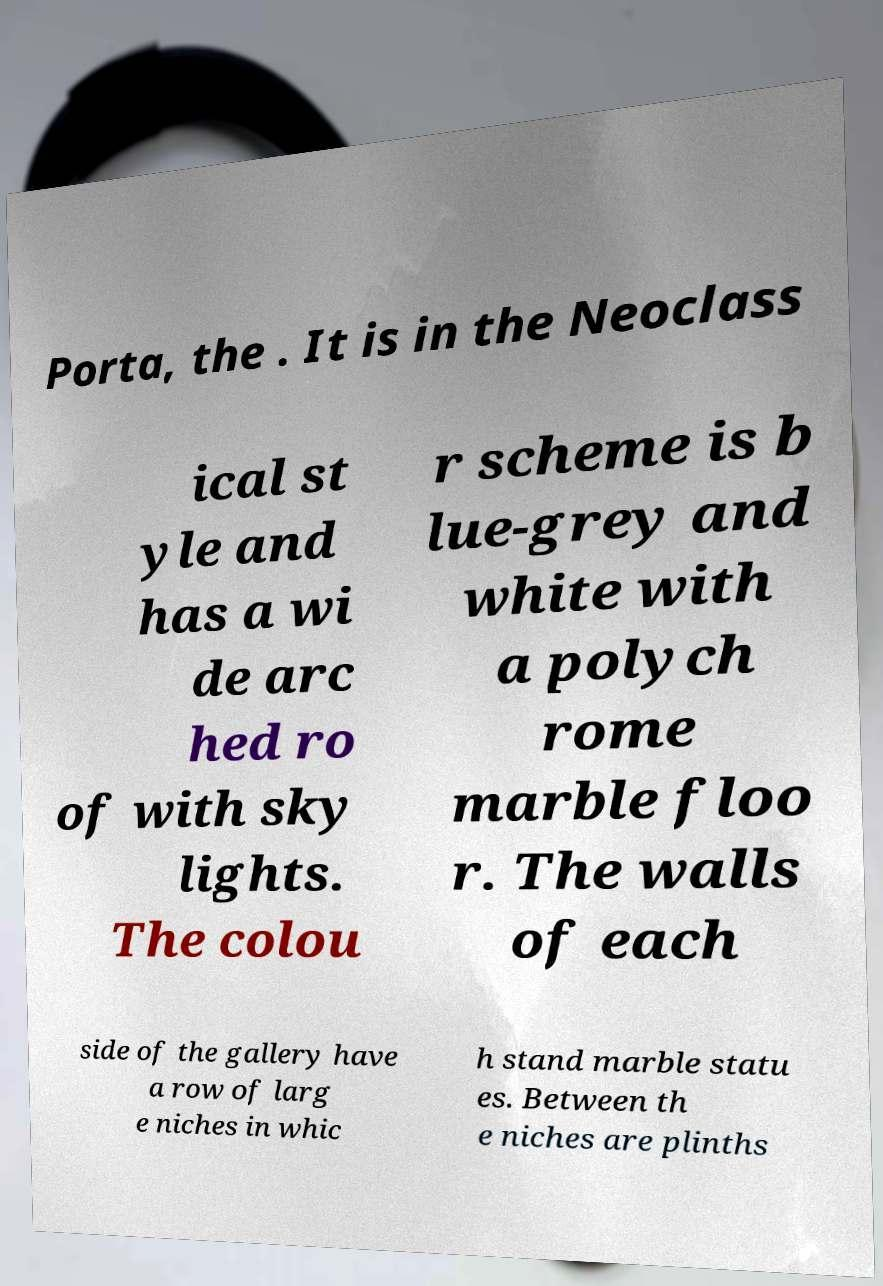Please read and relay the text visible in this image. What does it say? Porta, the . It is in the Neoclass ical st yle and has a wi de arc hed ro of with sky lights. The colou r scheme is b lue-grey and white with a polych rome marble floo r. The walls of each side of the gallery have a row of larg e niches in whic h stand marble statu es. Between th e niches are plinths 